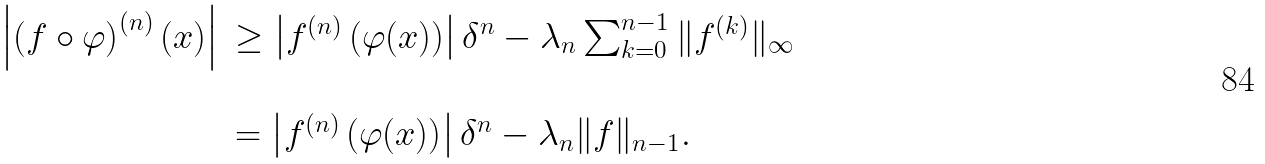<formula> <loc_0><loc_0><loc_500><loc_500>\begin{array} { l l } \left | \left ( f \circ \varphi \right ) ^ { ( n ) } ( x ) \right | & \geq \left | f ^ { ( n ) } \left ( \varphi ( x ) \right ) \right | \delta ^ { n } - \lambda _ { n } \sum _ { k = 0 } ^ { n - 1 } \| f ^ { ( k ) } \| _ { \infty } \\ & \\ & = \left | f ^ { ( n ) } \left ( \varphi ( x ) \right ) \right | \delta ^ { n } - \lambda _ { n } \| f \| _ { n - 1 } . \end{array}</formula> 